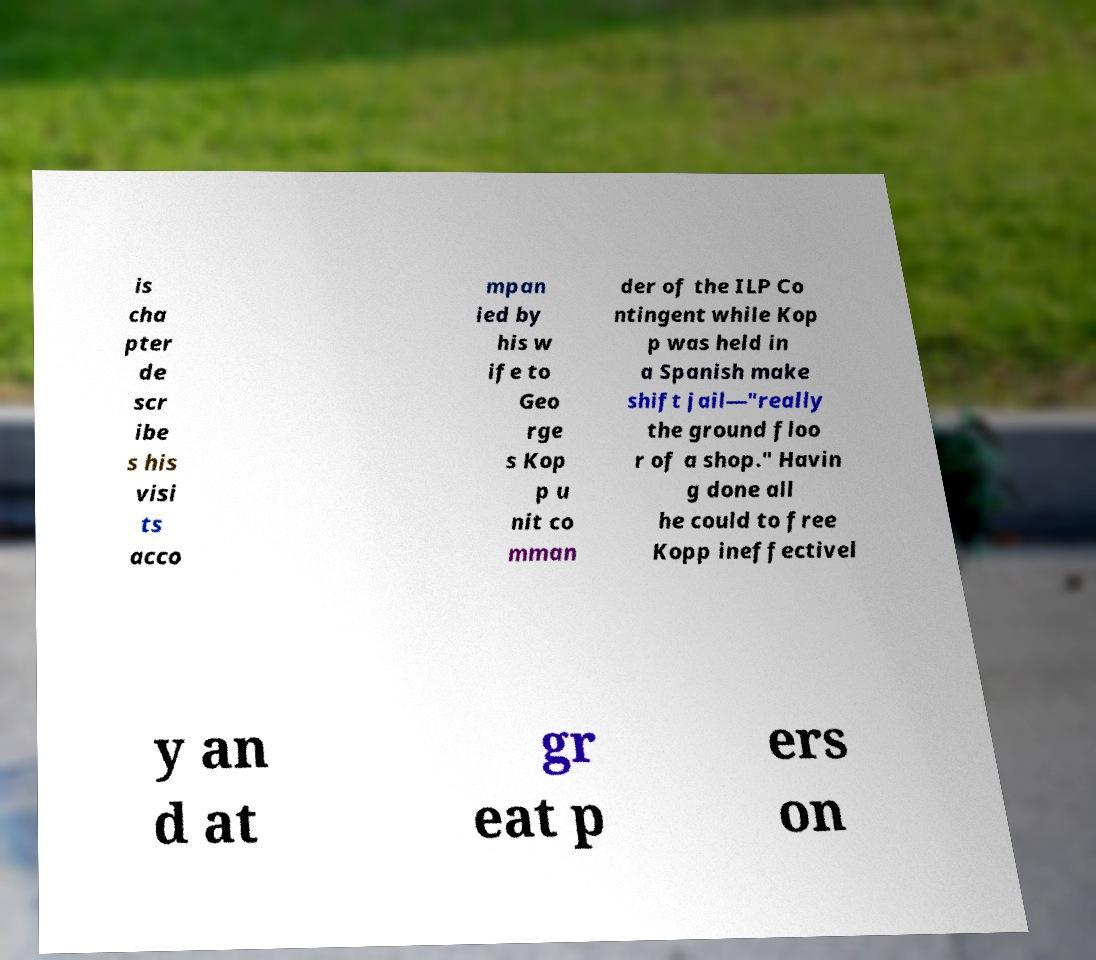Could you extract and type out the text from this image? is cha pter de scr ibe s his visi ts acco mpan ied by his w ife to Geo rge s Kop p u nit co mman der of the ILP Co ntingent while Kop p was held in a Spanish make shift jail—"really the ground floo r of a shop." Havin g done all he could to free Kopp ineffectivel y an d at gr eat p ers on 